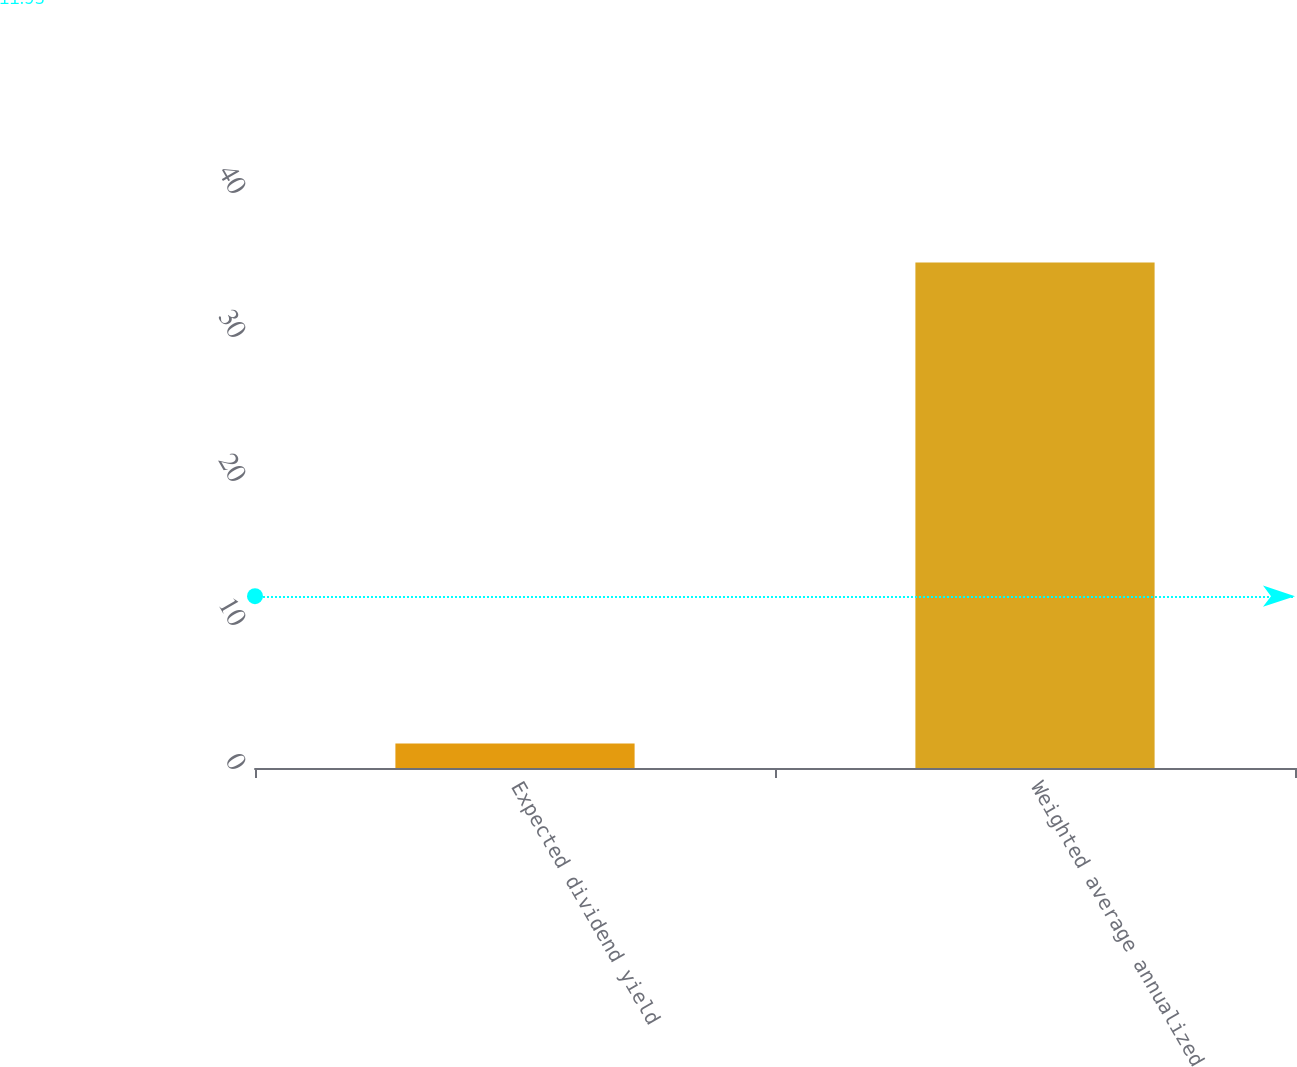Convert chart to OTSL. <chart><loc_0><loc_0><loc_500><loc_500><bar_chart><fcel>Expected dividend yield<fcel>Weighted average annualized<nl><fcel>1.7<fcel>35.1<nl></chart> 